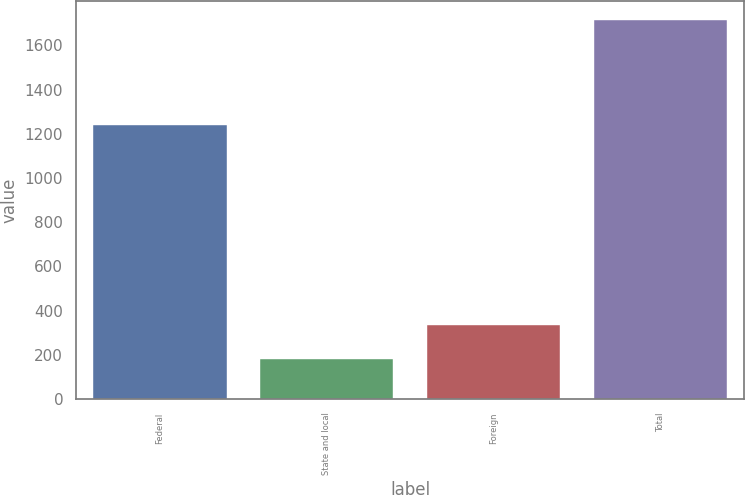Convert chart. <chart><loc_0><loc_0><loc_500><loc_500><bar_chart><fcel>Federal<fcel>State and local<fcel>Foreign<fcel>Total<nl><fcel>1239<fcel>183<fcel>336.1<fcel>1714<nl></chart> 